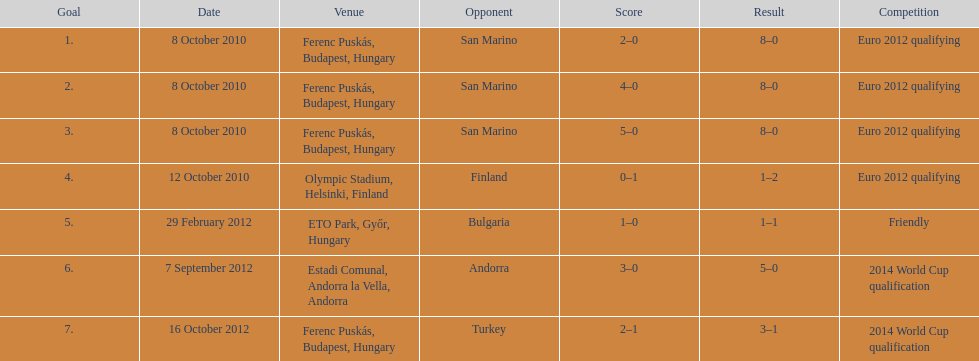When was ádám szalai's debut international goal made? 8 October 2010. 